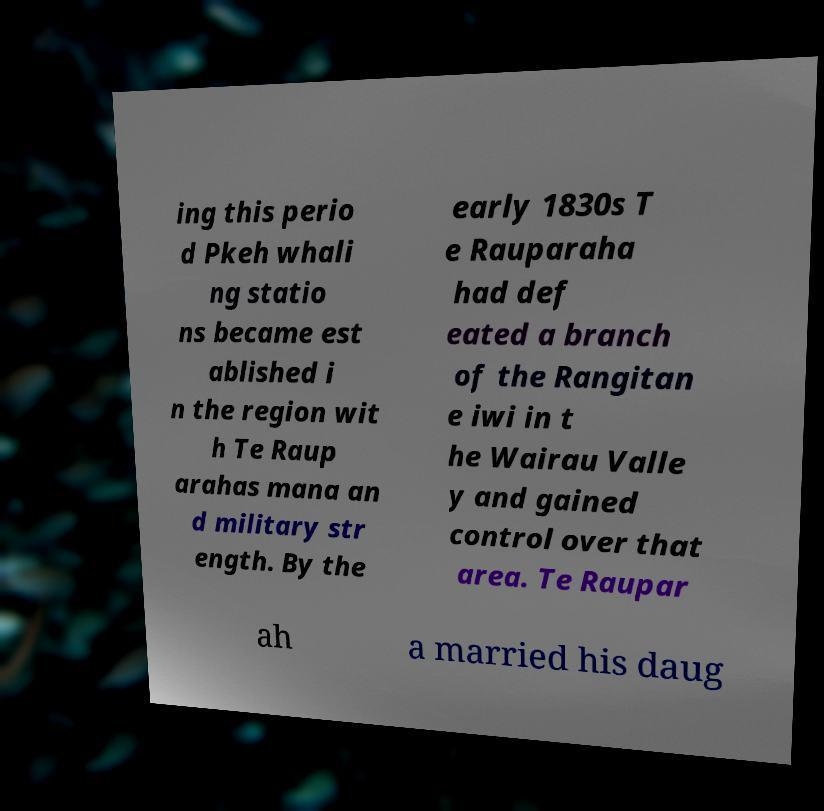I need the written content from this picture converted into text. Can you do that? ing this perio d Pkeh whali ng statio ns became est ablished i n the region wit h Te Raup arahas mana an d military str ength. By the early 1830s T e Rauparaha had def eated a branch of the Rangitan e iwi in t he Wairau Valle y and gained control over that area. Te Raupar ah a married his daug 